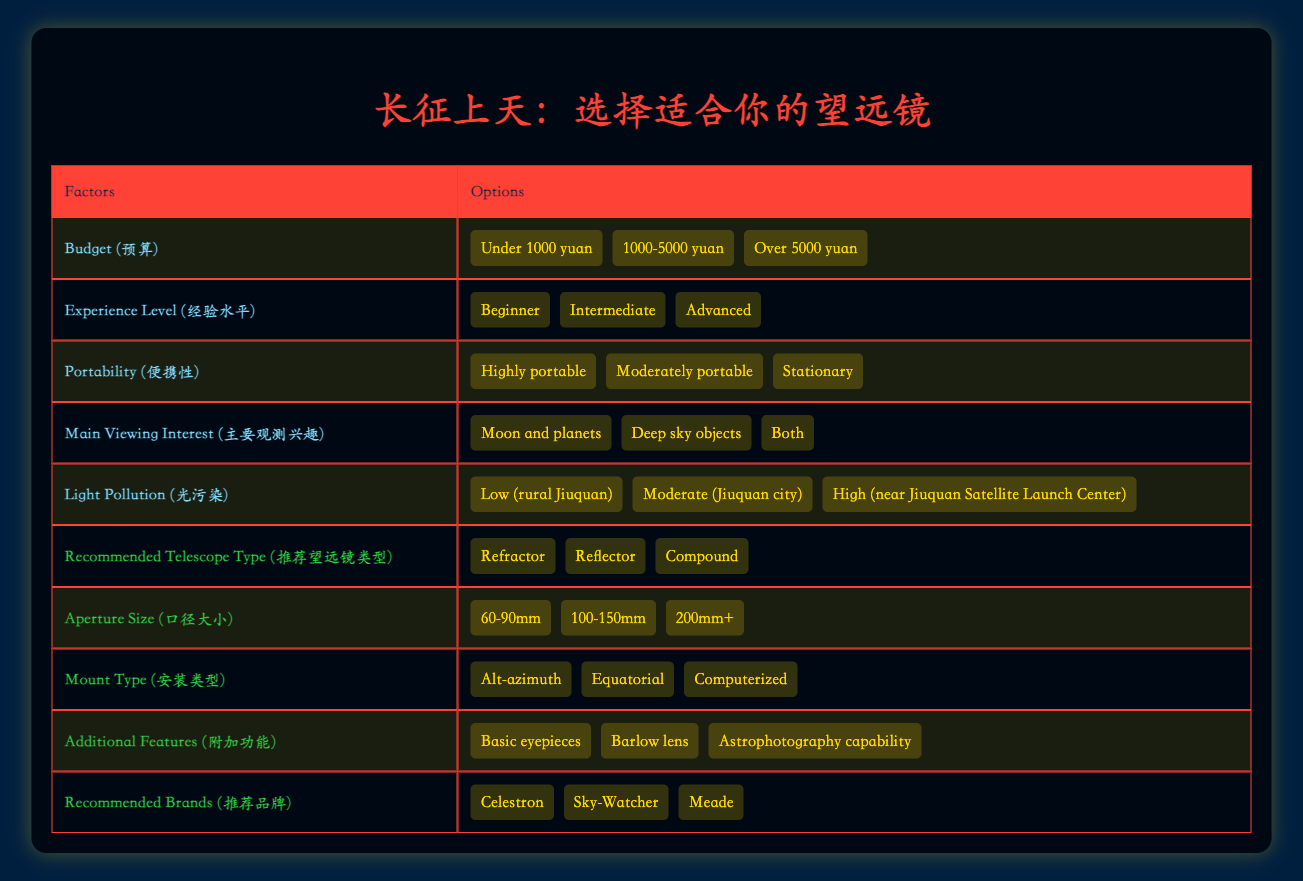What is the recommended telescope type if the budget is over 5000 yuan? From the table, we can see that when considering higher budgets, the recommended telescope type remains as "Refractor," "Reflector," and "Compound," with no specific exclusivity to any in that price range.
Answer: Refractor, Reflector, Compound Is a computerized mount type suitable for beginners? The table shows that a computerized mount type can be beneficial for users of all experience levels, including beginners, as it simplifies the stargazing process by automating tracking.
Answer: Yes What aperture size should be considered for someone interested in deep sky objects with a moderate budget? For someone interested in deep sky objects who has a moderate budget (1000-5000 yuan), the aperture size recommended would generally be 100-150mm, as it provides the necessary light-gathering capability for such observations.
Answer: 100-150mm How many options are available for light pollution conditions? The table lists three options for light pollution conditions: "Low (rural Jiuquan)," "Moderate (Jiuquan city)," and "High (near Jiuquan Satellite Launch Center)." Therefore, the total number of options is three.
Answer: 3 If someone wants to observe both the moon and deep sky objects, which additional feature may be most beneficial? For someone interested in both observing the moon and deep sky objects, having an "Astrophotography capability" as an additional feature would be most beneficial, allowing for enhanced capturing of images across varied celestial targets.
Answer: Astrophotography capability What is the average number of recommended brands listed for telescopes? The table indicates three recommended brands: "Celestron," "Sky-Watcher," and "Meade." Therefore, to find the average, we simply divide the total number (which is 3) by itself, as it's just a count. Thus, the average is 3.
Answer: 3 Does the table suggest that a highly portable telescope is suitable for advanced users? The table does not explicitly state restrictions on the type of telescope based on experience level when it comes to portability, meaning that a highly portable telescope can indeed be used by advanced users as well.
Answer: Yes Based on the table, which combination of conditions would likely lead to a recommendation for a reflector telescope? A likely combination for recommending a reflector telescope would be when the user has a budget of 1000-5000 yuan, is at an intermediate or advanced experience level, and has moderate to high light pollution, as reflectors usually excel in deep sky viewing, which might be the user's area of interest.
Answer: Budget 1000-5000 yuan, Intermediate or Advanced, Moderate to High light pollution 